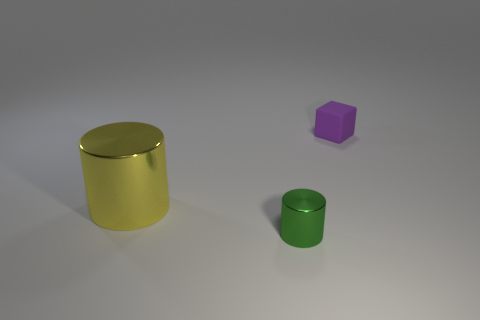Subtract all cylinders. How many objects are left? 1 Subtract 0 gray cylinders. How many objects are left? 3 Subtract 1 blocks. How many blocks are left? 0 Subtract all red cylinders. Subtract all purple cubes. How many cylinders are left? 2 Subtract all brown cylinders. How many brown cubes are left? 0 Subtract all tiny blocks. Subtract all tiny green metal things. How many objects are left? 1 Add 1 metallic cylinders. How many metallic cylinders are left? 3 Add 1 purple things. How many purple things exist? 2 Add 2 tiny green matte balls. How many objects exist? 5 